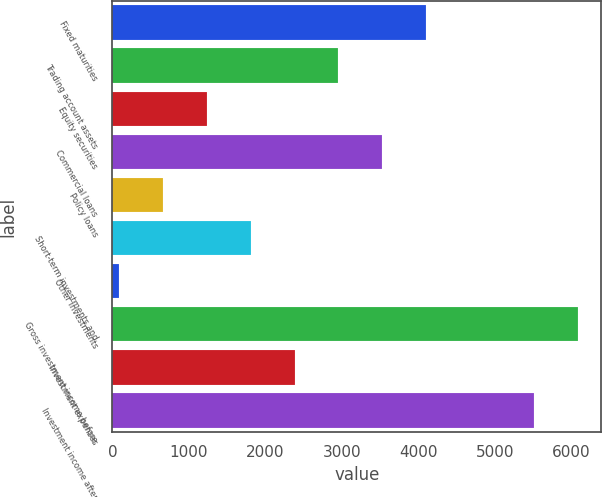Convert chart. <chart><loc_0><loc_0><loc_500><loc_500><bar_chart><fcel>Fixed maturities<fcel>Trading account assets<fcel>Equity securities<fcel>Commercial loans<fcel>Policy loans<fcel>Short-term investments and<fcel>Other investments<fcel>Gross investment income before<fcel>Investment expenses<fcel>Investment income after<nl><fcel>4100.2<fcel>2955<fcel>1237.2<fcel>3527.6<fcel>664.6<fcel>1809.8<fcel>92<fcel>6089.6<fcel>2382.4<fcel>5517<nl></chart> 